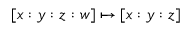Convert formula to latex. <formula><loc_0><loc_0><loc_500><loc_500>[ x \colon y \colon z \colon w ] \mapsto [ x \colon y \colon z ]</formula> 